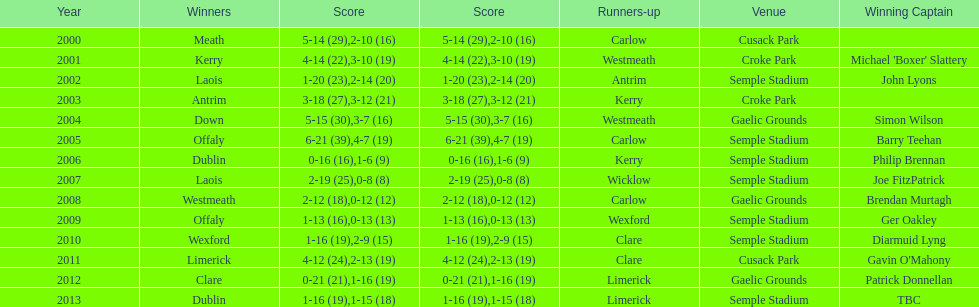Who was the victor post 2007? Laois. 